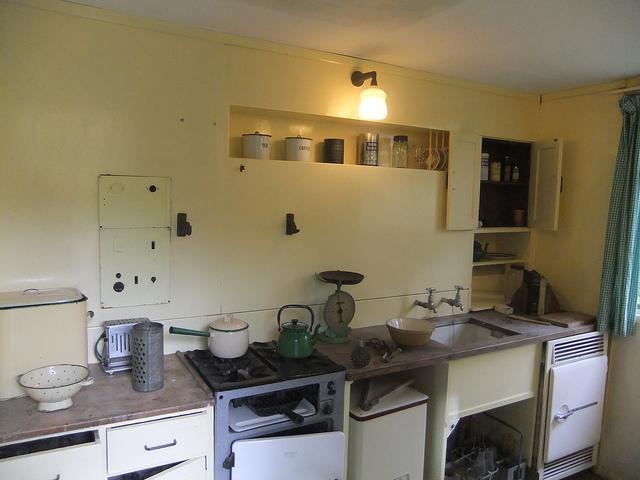How many adult elephants are in this scene?
Give a very brief answer. 0. 